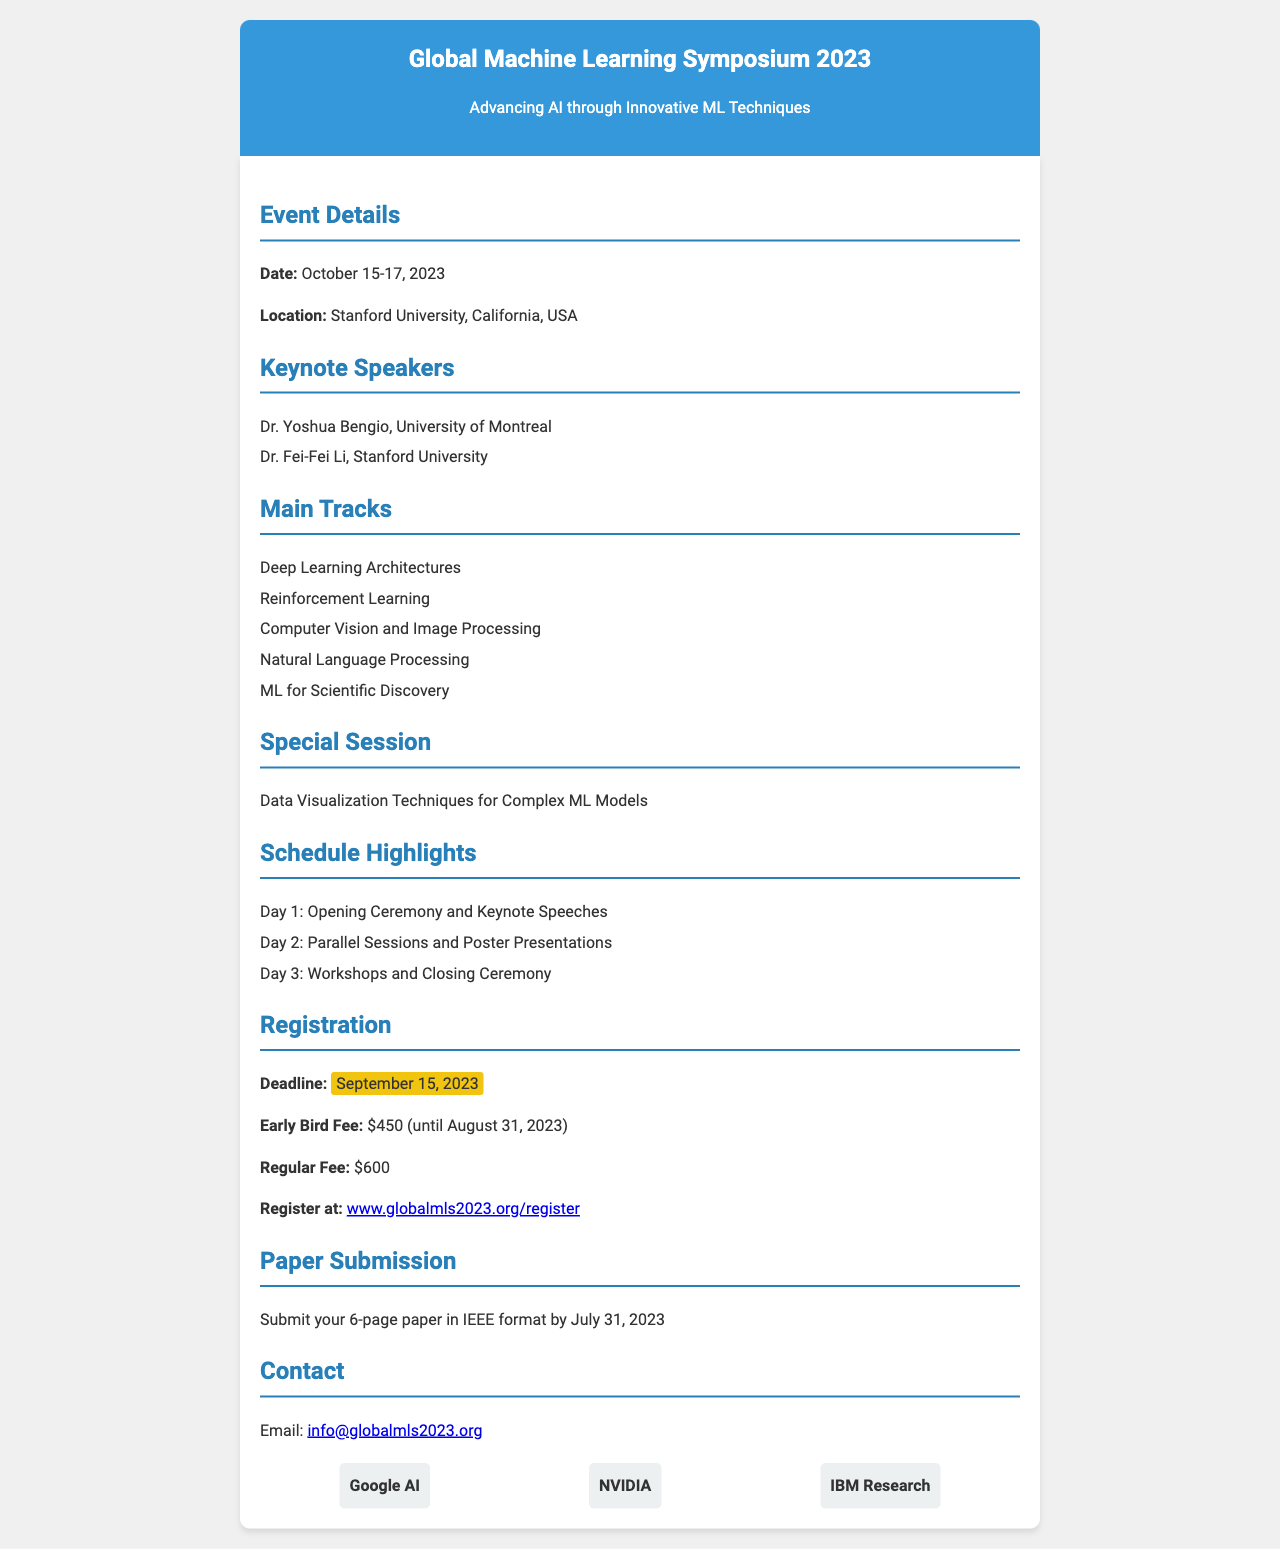What are the dates of the symposium? The dates of the symposium are provided in the event details section, which states October 15-17, 2023.
Answer: October 15-17, 2023 Who is one of the keynote speakers? The document lists Dr. Yoshua Bengio and Dr. Fei-Fei Li as keynote speakers, both of whom are mentioned under the Keynote Speakers section.
Answer: Dr. Yoshua Bengio What is the regular registration fee? The regular fee for registration is specified in the registration section of the document, which mentions $600.
Answer: $600 When is the early bird registration deadline? The early bird registration deadline is found in the registration section, indicating it is August 31, 2023.
Answer: August 31, 2023 What is the theme of the special session? The theme of the special session is included in the document under Special Session, which specifies data visualization techniques for complex ML models.
Answer: Data Visualization Techniques for Complex ML Models How many days does the symposium last? The total days of the event can be inferred from the dates provided, indicating it spans three days.
Answer: Three days What is the deadline for paper submission? The deadline for paper submission is stated in the Paper Submission section, which is July 31, 2023.
Answer: July 31, 2023 What university is hosting the event? The hosting university is mentioned in the event details, which indicates Stanford University as the location.
Answer: Stanford University Which company is one of the sponsors? The sponsors are listed at the end of the document, and one of them is Google AI.
Answer: Google AI 